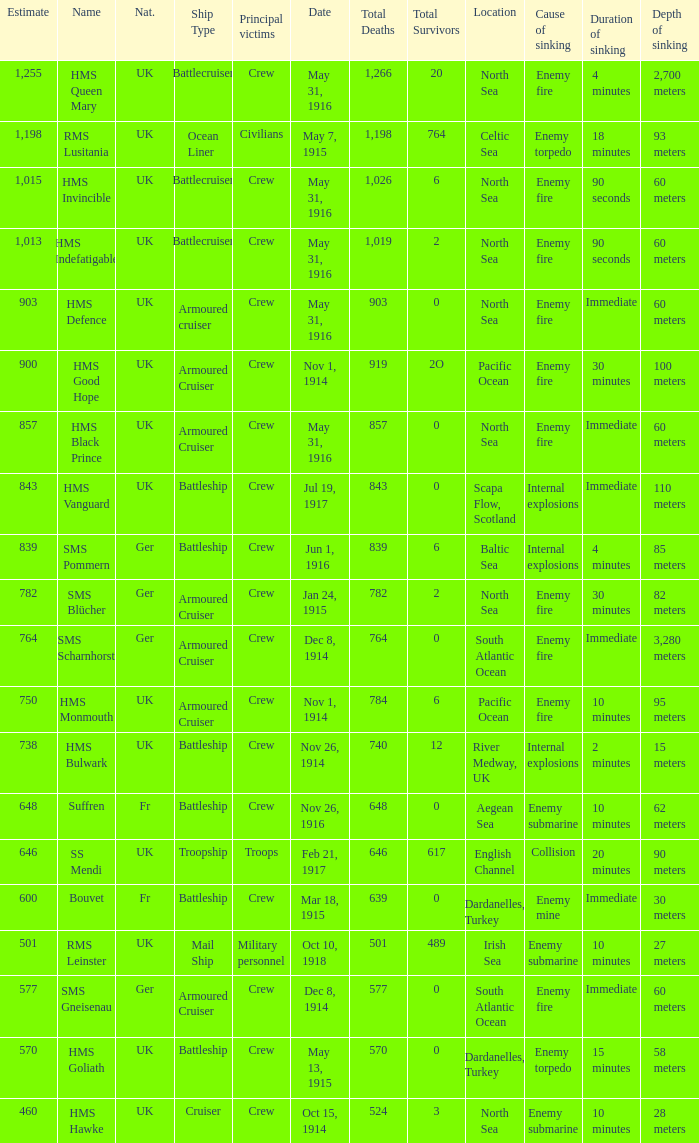What is the nationality of the ship when the principle victims are civilians? UK. 